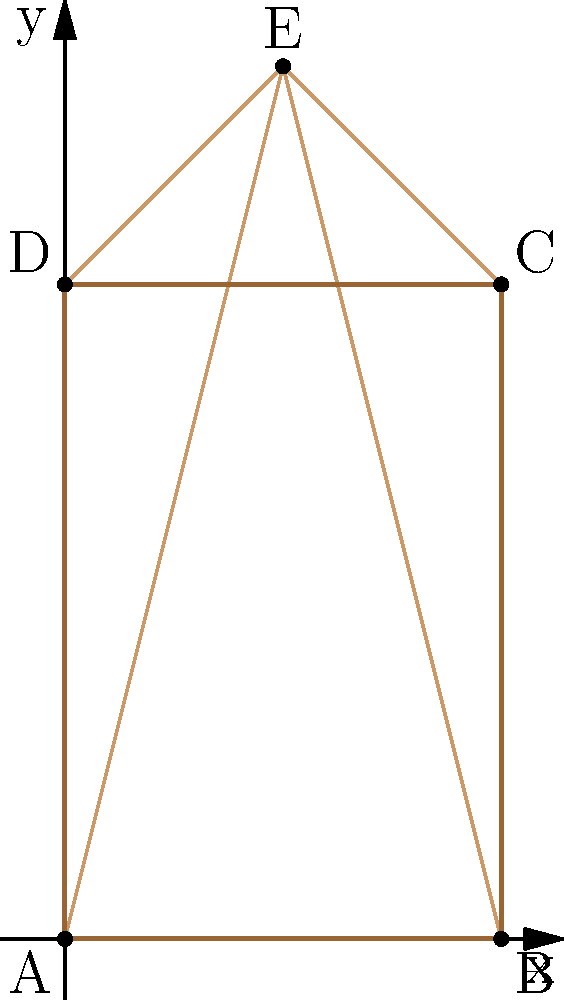As a Sudanese architect studying the geometric properties of ancient pyramids, you've come across a unique pyramid structure at the archaeological site of Meroe. The base of this pyramid is a rectangle with dimensions $a = 2$ units and $b = 3$ units, and its height is $h = 4$ units. The apex of the pyramid is directly above the center of the base. Using a three-dimensional coordinate system where the base lies on the xy-plane and the z-axis represents height, what are the coordinates of the apex (point E) of this pyramid? To find the coordinates of the apex (point E), we need to follow these steps:

1) First, let's establish our coordinate system:
   - The base of the pyramid lies on the xy-plane.
   - One corner of the base (point A) is at the origin (0,0,0).
   - The x-axis runs along the side of length $a$.
   - The y-axis runs along the side of length $b$.
   - The z-axis represents the height.

2) The base of the pyramid is a rectangle with dimensions:
   - Length (along x-axis) = $a = 2$ units
   - Width (along y-axis) = $b = 3$ units

3) The apex is directly above the center of the base. To find its x and y coordinates:
   - x-coordinate of the center = $a/2 = 2/2 = 1$ unit
   - y-coordinate of the center = $b/2 = 3/2 = 1.5$ units

4) The z-coordinate of the apex is simply the height of the pyramid:
   - z-coordinate = $h = 4$ units

5) Therefore, the coordinates of the apex E are $(1, 1.5, 4)$.
Answer: $(1, 1.5, 4)$ 